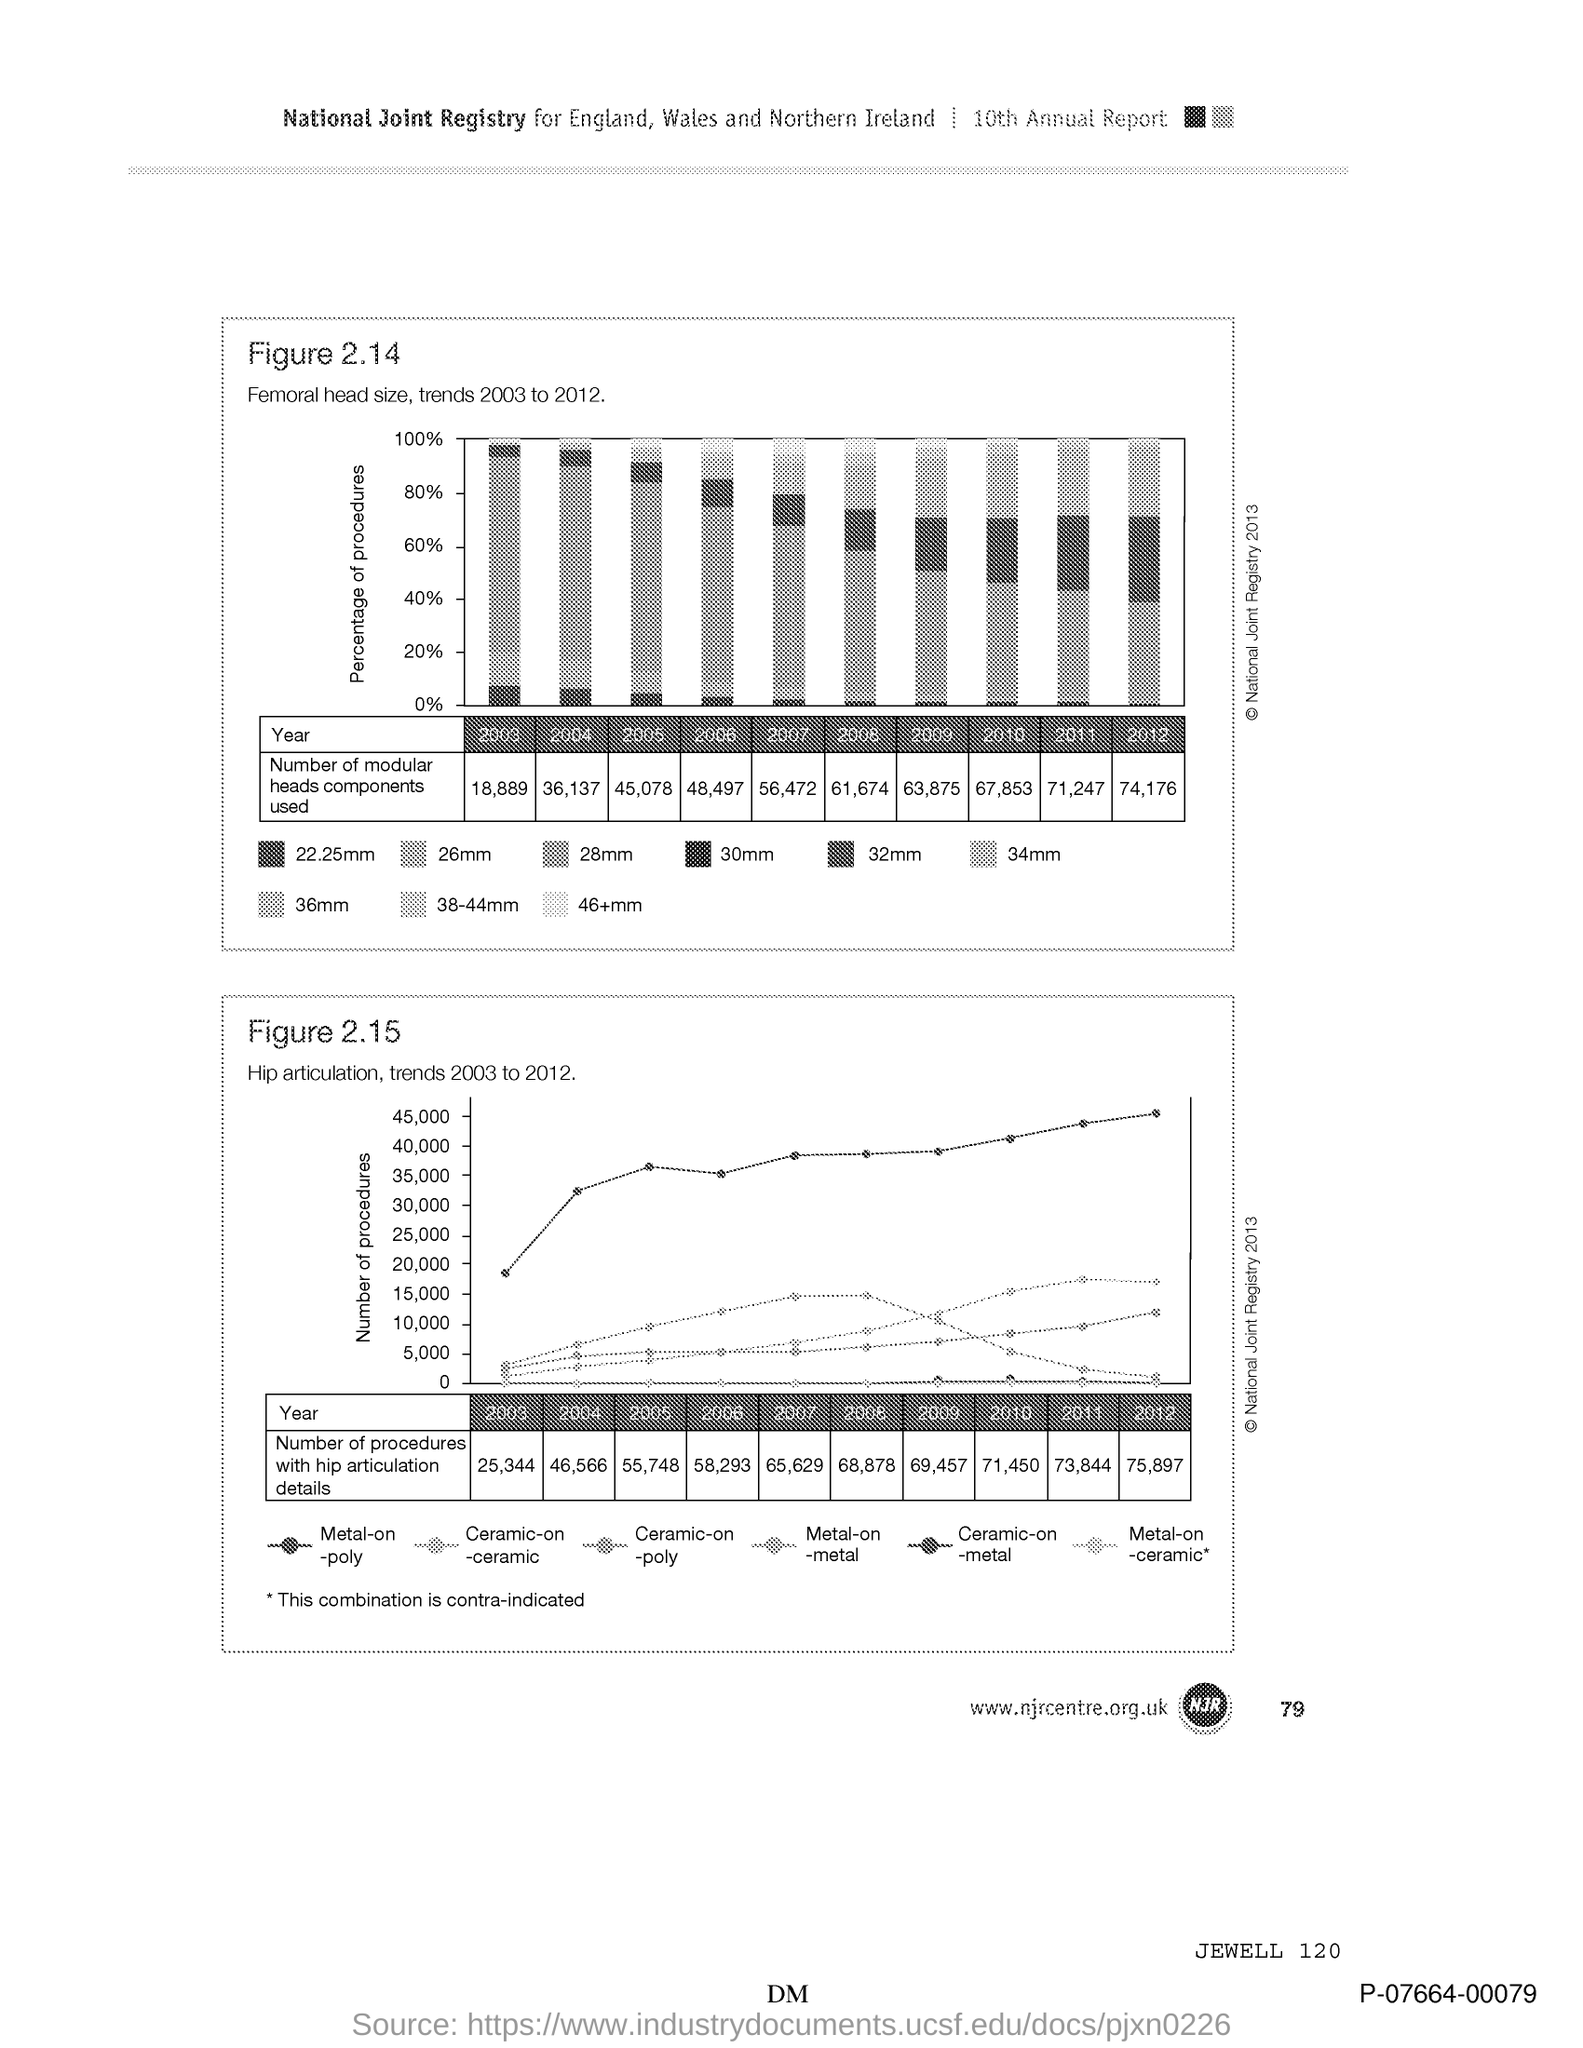Outline some significant characteristics in this image. The number at the bottom right of the page is 79. 